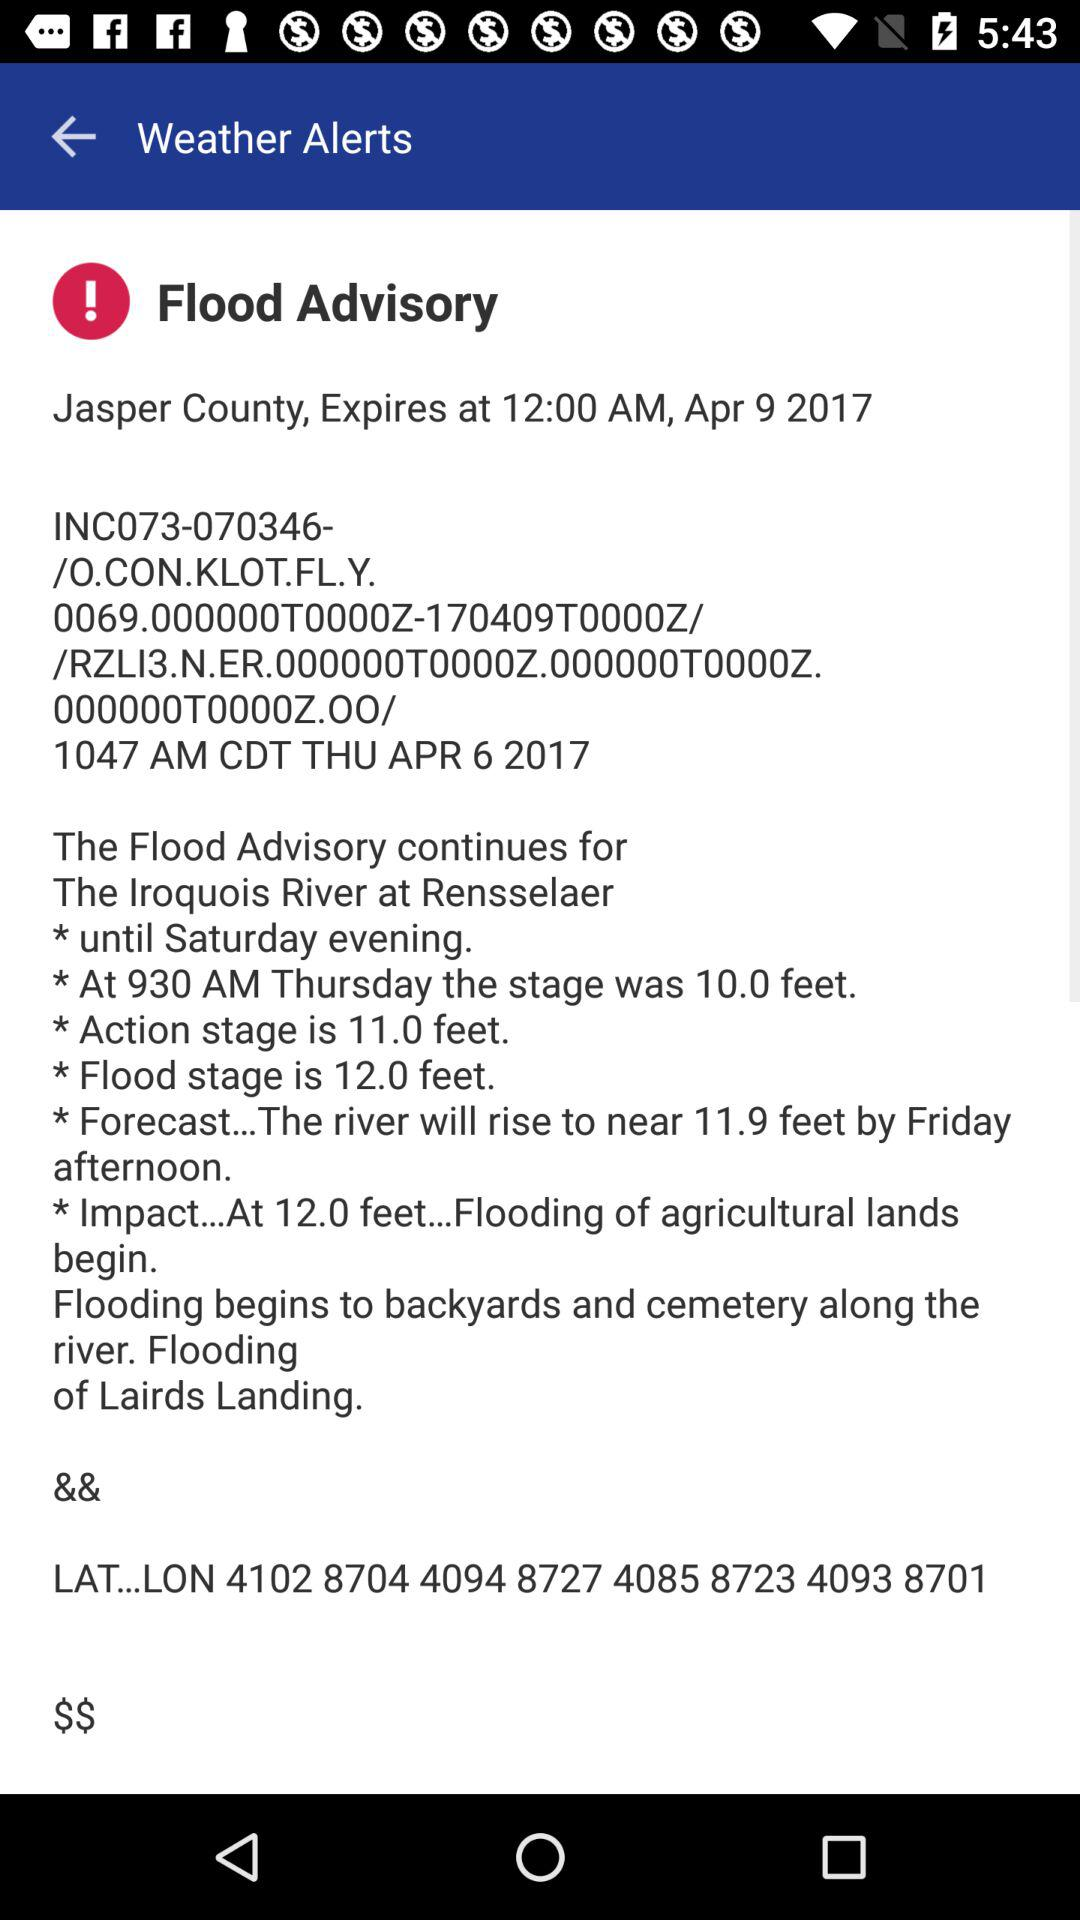What is the forecast? The forecast is that the river will rise to near 11.9 feet by Friday afternoon. 